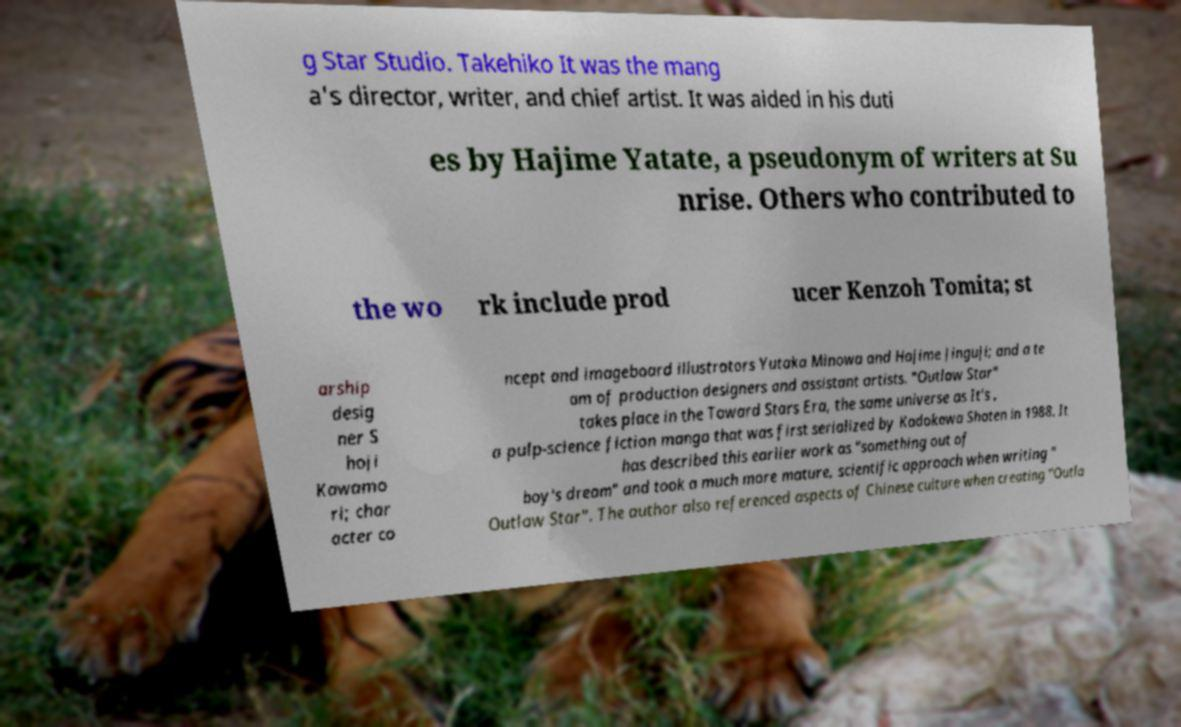There's text embedded in this image that I need extracted. Can you transcribe it verbatim? g Star Studio. Takehiko It was the mang a's director, writer, and chief artist. It was aided in his duti es by Hajime Yatate, a pseudonym of writers at Su nrise. Others who contributed to the wo rk include prod ucer Kenzoh Tomita; st arship desig ner S hoji Kawamo ri; char acter co ncept and imageboard illustrators Yutaka Minowa and Hajime Jinguji; and a te am of production designers and assistant artists. "Outlaw Star" takes place in the Toward Stars Era, the same universe as It's , a pulp-science fiction manga that was first serialized by Kadokawa Shoten in 1988. It has described this earlier work as "something out of boy's dream" and took a much more mature, scientific approach when writing " Outlaw Star". The author also referenced aspects of Chinese culture when creating "Outla 